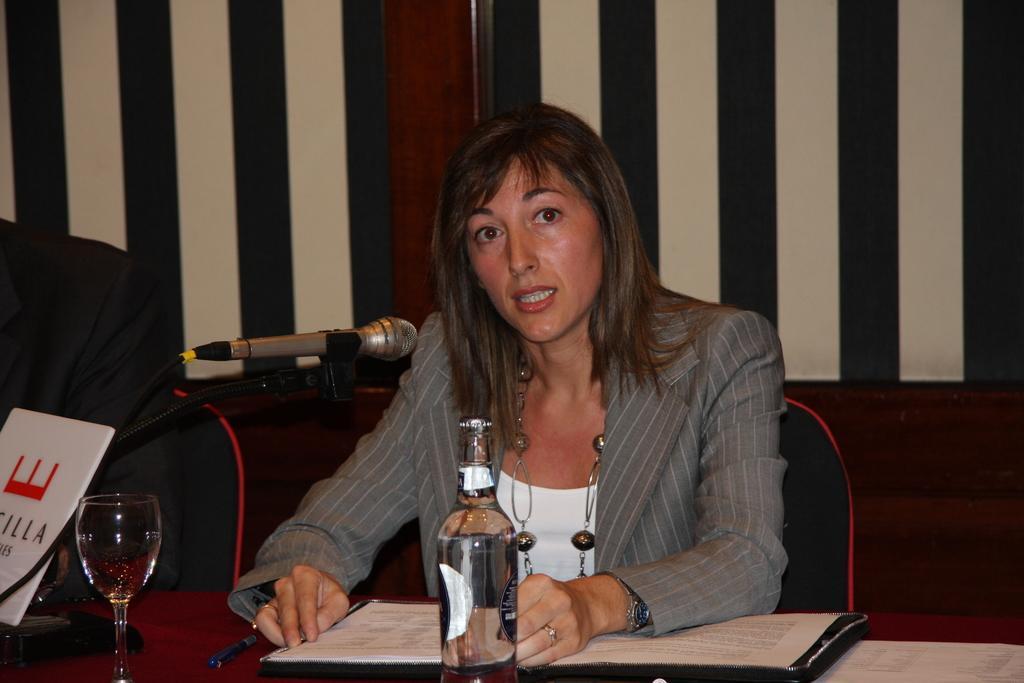Please provide a concise description of this image. In this image we can see a lady sitting on a chair. In front of the lady we can see a mic and there is a book, bottle, glass and a pen on the table. Behind the lady we can see a wall. On the left side, we can see a person and a board with text. 